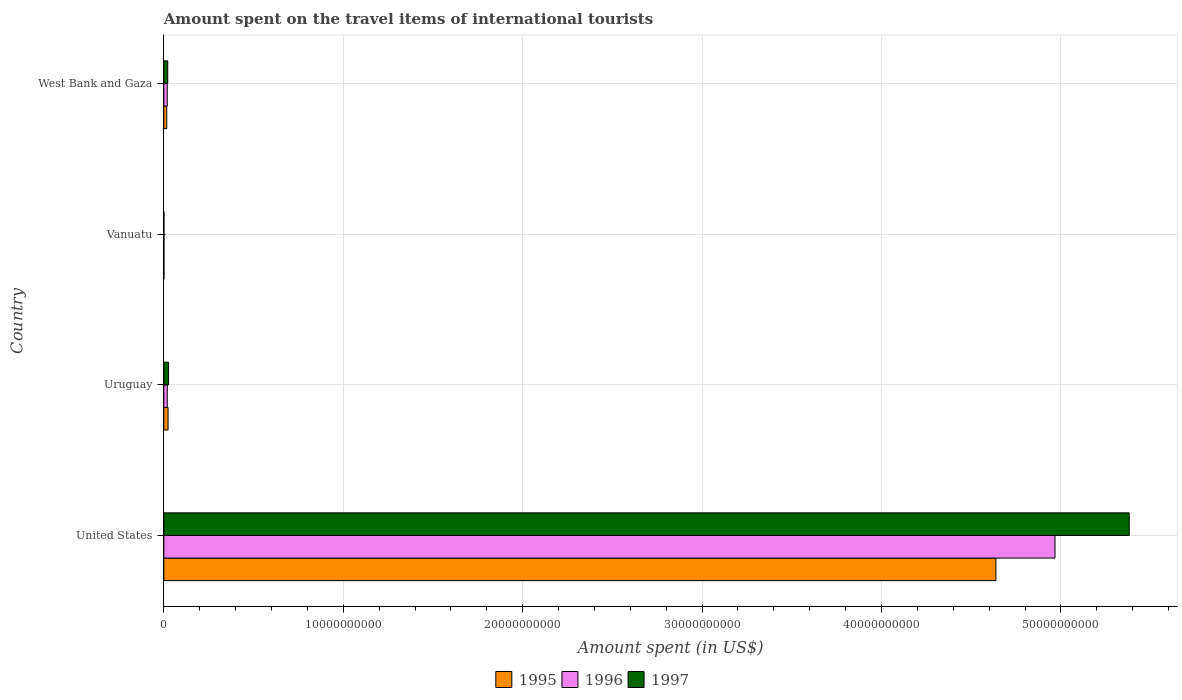How many different coloured bars are there?
Keep it short and to the point. 3. Are the number of bars per tick equal to the number of legend labels?
Your response must be concise. Yes. How many bars are there on the 3rd tick from the top?
Provide a short and direct response. 3. What is the label of the 2nd group of bars from the top?
Your answer should be very brief. Vanuatu. What is the amount spent on the travel items of international tourists in 1996 in Uruguay?
Offer a terse response. 1.92e+08. Across all countries, what is the maximum amount spent on the travel items of international tourists in 1996?
Make the answer very short. 4.97e+1. Across all countries, what is the minimum amount spent on the travel items of international tourists in 1996?
Your answer should be very brief. 5.00e+06. In which country was the amount spent on the travel items of international tourists in 1996 minimum?
Give a very brief answer. Vanuatu. What is the total amount spent on the travel items of international tourists in 1997 in the graph?
Provide a short and direct response. 5.43e+1. What is the difference between the amount spent on the travel items of international tourists in 1997 in United States and that in Uruguay?
Make the answer very short. 5.35e+1. What is the difference between the amount spent on the travel items of international tourists in 1997 in Uruguay and the amount spent on the travel items of international tourists in 1995 in Vanuatu?
Keep it short and to the point. 2.59e+08. What is the average amount spent on the travel items of international tourists in 1997 per country?
Offer a terse response. 1.36e+1. What is the difference between the amount spent on the travel items of international tourists in 1997 and amount spent on the travel items of international tourists in 1995 in Uruguay?
Offer a terse response. 2.80e+07. In how many countries, is the amount spent on the travel items of international tourists in 1995 greater than 50000000000 US$?
Ensure brevity in your answer.  0. What is the ratio of the amount spent on the travel items of international tourists in 1997 in United States to that in West Bank and Gaza?
Ensure brevity in your answer.  246.83. What is the difference between the highest and the second highest amount spent on the travel items of international tourists in 1997?
Offer a terse response. 5.35e+1. What is the difference between the highest and the lowest amount spent on the travel items of international tourists in 1995?
Ensure brevity in your answer.  4.64e+1. Is the sum of the amount spent on the travel items of international tourists in 1997 in Vanuatu and West Bank and Gaza greater than the maximum amount spent on the travel items of international tourists in 1995 across all countries?
Ensure brevity in your answer.  No. What does the 2nd bar from the top in Vanuatu represents?
Provide a short and direct response. 1996. What does the 1st bar from the bottom in Uruguay represents?
Offer a terse response. 1995. Is it the case that in every country, the sum of the amount spent on the travel items of international tourists in 1997 and amount spent on the travel items of international tourists in 1996 is greater than the amount spent on the travel items of international tourists in 1995?
Provide a succinct answer. Yes. What is the difference between two consecutive major ticks on the X-axis?
Provide a short and direct response. 1.00e+1. Does the graph contain grids?
Ensure brevity in your answer.  Yes. Where does the legend appear in the graph?
Offer a very short reply. Bottom center. How many legend labels are there?
Keep it short and to the point. 3. What is the title of the graph?
Keep it short and to the point. Amount spent on the travel items of international tourists. What is the label or title of the X-axis?
Your answer should be very brief. Amount spent (in US$). What is the Amount spent (in US$) in 1995 in United States?
Your response must be concise. 4.64e+1. What is the Amount spent (in US$) in 1996 in United States?
Your response must be concise. 4.97e+1. What is the Amount spent (in US$) of 1997 in United States?
Keep it short and to the point. 5.38e+1. What is the Amount spent (in US$) in 1995 in Uruguay?
Provide a succinct answer. 2.36e+08. What is the Amount spent (in US$) of 1996 in Uruguay?
Make the answer very short. 1.92e+08. What is the Amount spent (in US$) of 1997 in Uruguay?
Provide a short and direct response. 2.64e+08. What is the Amount spent (in US$) of 1995 in Vanuatu?
Keep it short and to the point. 5.00e+06. What is the Amount spent (in US$) in 1995 in West Bank and Gaza?
Provide a short and direct response. 1.62e+08. What is the Amount spent (in US$) in 1996 in West Bank and Gaza?
Your answer should be compact. 1.91e+08. What is the Amount spent (in US$) in 1997 in West Bank and Gaza?
Ensure brevity in your answer.  2.18e+08. Across all countries, what is the maximum Amount spent (in US$) of 1995?
Offer a terse response. 4.64e+1. Across all countries, what is the maximum Amount spent (in US$) in 1996?
Offer a terse response. 4.97e+1. Across all countries, what is the maximum Amount spent (in US$) in 1997?
Keep it short and to the point. 5.38e+1. Across all countries, what is the minimum Amount spent (in US$) in 1995?
Your answer should be very brief. 5.00e+06. Across all countries, what is the minimum Amount spent (in US$) in 1996?
Make the answer very short. 5.00e+06. Across all countries, what is the minimum Amount spent (in US$) in 1997?
Offer a terse response. 5.00e+06. What is the total Amount spent (in US$) in 1995 in the graph?
Give a very brief answer. 4.68e+1. What is the total Amount spent (in US$) of 1996 in the graph?
Offer a terse response. 5.01e+1. What is the total Amount spent (in US$) in 1997 in the graph?
Keep it short and to the point. 5.43e+1. What is the difference between the Amount spent (in US$) in 1995 in United States and that in Uruguay?
Ensure brevity in your answer.  4.61e+1. What is the difference between the Amount spent (in US$) in 1996 in United States and that in Uruguay?
Your response must be concise. 4.95e+1. What is the difference between the Amount spent (in US$) of 1997 in United States and that in Uruguay?
Ensure brevity in your answer.  5.35e+1. What is the difference between the Amount spent (in US$) of 1995 in United States and that in Vanuatu?
Your response must be concise. 4.64e+1. What is the difference between the Amount spent (in US$) of 1996 in United States and that in Vanuatu?
Ensure brevity in your answer.  4.97e+1. What is the difference between the Amount spent (in US$) in 1997 in United States and that in Vanuatu?
Offer a terse response. 5.38e+1. What is the difference between the Amount spent (in US$) of 1995 in United States and that in West Bank and Gaza?
Keep it short and to the point. 4.62e+1. What is the difference between the Amount spent (in US$) of 1996 in United States and that in West Bank and Gaza?
Provide a short and direct response. 4.95e+1. What is the difference between the Amount spent (in US$) in 1997 in United States and that in West Bank and Gaza?
Make the answer very short. 5.36e+1. What is the difference between the Amount spent (in US$) in 1995 in Uruguay and that in Vanuatu?
Provide a short and direct response. 2.31e+08. What is the difference between the Amount spent (in US$) of 1996 in Uruguay and that in Vanuatu?
Provide a succinct answer. 1.87e+08. What is the difference between the Amount spent (in US$) in 1997 in Uruguay and that in Vanuatu?
Your answer should be very brief. 2.59e+08. What is the difference between the Amount spent (in US$) of 1995 in Uruguay and that in West Bank and Gaza?
Your answer should be very brief. 7.40e+07. What is the difference between the Amount spent (in US$) in 1996 in Uruguay and that in West Bank and Gaza?
Offer a terse response. 1.00e+06. What is the difference between the Amount spent (in US$) in 1997 in Uruguay and that in West Bank and Gaza?
Make the answer very short. 4.60e+07. What is the difference between the Amount spent (in US$) in 1995 in Vanuatu and that in West Bank and Gaza?
Your answer should be very brief. -1.57e+08. What is the difference between the Amount spent (in US$) of 1996 in Vanuatu and that in West Bank and Gaza?
Your response must be concise. -1.86e+08. What is the difference between the Amount spent (in US$) in 1997 in Vanuatu and that in West Bank and Gaza?
Give a very brief answer. -2.13e+08. What is the difference between the Amount spent (in US$) of 1995 in United States and the Amount spent (in US$) of 1996 in Uruguay?
Provide a succinct answer. 4.62e+1. What is the difference between the Amount spent (in US$) of 1995 in United States and the Amount spent (in US$) of 1997 in Uruguay?
Provide a short and direct response. 4.61e+1. What is the difference between the Amount spent (in US$) in 1996 in United States and the Amount spent (in US$) in 1997 in Uruguay?
Ensure brevity in your answer.  4.94e+1. What is the difference between the Amount spent (in US$) in 1995 in United States and the Amount spent (in US$) in 1996 in Vanuatu?
Offer a terse response. 4.64e+1. What is the difference between the Amount spent (in US$) of 1995 in United States and the Amount spent (in US$) of 1997 in Vanuatu?
Offer a very short reply. 4.64e+1. What is the difference between the Amount spent (in US$) of 1996 in United States and the Amount spent (in US$) of 1997 in Vanuatu?
Provide a short and direct response. 4.97e+1. What is the difference between the Amount spent (in US$) of 1995 in United States and the Amount spent (in US$) of 1996 in West Bank and Gaza?
Your answer should be compact. 4.62e+1. What is the difference between the Amount spent (in US$) in 1995 in United States and the Amount spent (in US$) in 1997 in West Bank and Gaza?
Offer a very short reply. 4.62e+1. What is the difference between the Amount spent (in US$) of 1996 in United States and the Amount spent (in US$) of 1997 in West Bank and Gaza?
Your response must be concise. 4.95e+1. What is the difference between the Amount spent (in US$) of 1995 in Uruguay and the Amount spent (in US$) of 1996 in Vanuatu?
Your response must be concise. 2.31e+08. What is the difference between the Amount spent (in US$) in 1995 in Uruguay and the Amount spent (in US$) in 1997 in Vanuatu?
Your answer should be very brief. 2.31e+08. What is the difference between the Amount spent (in US$) of 1996 in Uruguay and the Amount spent (in US$) of 1997 in Vanuatu?
Your response must be concise. 1.87e+08. What is the difference between the Amount spent (in US$) in 1995 in Uruguay and the Amount spent (in US$) in 1996 in West Bank and Gaza?
Provide a short and direct response. 4.50e+07. What is the difference between the Amount spent (in US$) of 1995 in Uruguay and the Amount spent (in US$) of 1997 in West Bank and Gaza?
Offer a very short reply. 1.80e+07. What is the difference between the Amount spent (in US$) of 1996 in Uruguay and the Amount spent (in US$) of 1997 in West Bank and Gaza?
Offer a very short reply. -2.60e+07. What is the difference between the Amount spent (in US$) in 1995 in Vanuatu and the Amount spent (in US$) in 1996 in West Bank and Gaza?
Provide a short and direct response. -1.86e+08. What is the difference between the Amount spent (in US$) in 1995 in Vanuatu and the Amount spent (in US$) in 1997 in West Bank and Gaza?
Your answer should be very brief. -2.13e+08. What is the difference between the Amount spent (in US$) in 1996 in Vanuatu and the Amount spent (in US$) in 1997 in West Bank and Gaza?
Your response must be concise. -2.13e+08. What is the average Amount spent (in US$) of 1995 per country?
Provide a succinct answer. 1.17e+1. What is the average Amount spent (in US$) of 1996 per country?
Keep it short and to the point. 1.25e+1. What is the average Amount spent (in US$) of 1997 per country?
Make the answer very short. 1.36e+1. What is the difference between the Amount spent (in US$) in 1995 and Amount spent (in US$) in 1996 in United States?
Give a very brief answer. -3.29e+09. What is the difference between the Amount spent (in US$) of 1995 and Amount spent (in US$) of 1997 in United States?
Provide a succinct answer. -7.43e+09. What is the difference between the Amount spent (in US$) in 1996 and Amount spent (in US$) in 1997 in United States?
Ensure brevity in your answer.  -4.14e+09. What is the difference between the Amount spent (in US$) in 1995 and Amount spent (in US$) in 1996 in Uruguay?
Give a very brief answer. 4.40e+07. What is the difference between the Amount spent (in US$) in 1995 and Amount spent (in US$) in 1997 in Uruguay?
Keep it short and to the point. -2.80e+07. What is the difference between the Amount spent (in US$) of 1996 and Amount spent (in US$) of 1997 in Uruguay?
Keep it short and to the point. -7.20e+07. What is the difference between the Amount spent (in US$) of 1995 and Amount spent (in US$) of 1997 in Vanuatu?
Give a very brief answer. 0. What is the difference between the Amount spent (in US$) in 1995 and Amount spent (in US$) in 1996 in West Bank and Gaza?
Give a very brief answer. -2.90e+07. What is the difference between the Amount spent (in US$) in 1995 and Amount spent (in US$) in 1997 in West Bank and Gaza?
Keep it short and to the point. -5.60e+07. What is the difference between the Amount spent (in US$) in 1996 and Amount spent (in US$) in 1997 in West Bank and Gaza?
Offer a terse response. -2.70e+07. What is the ratio of the Amount spent (in US$) in 1995 in United States to that in Uruguay?
Provide a succinct answer. 196.52. What is the ratio of the Amount spent (in US$) in 1996 in United States to that in Uruguay?
Give a very brief answer. 258.71. What is the ratio of the Amount spent (in US$) in 1997 in United States to that in Uruguay?
Your answer should be compact. 203.82. What is the ratio of the Amount spent (in US$) in 1995 in United States to that in Vanuatu?
Offer a terse response. 9275.8. What is the ratio of the Amount spent (in US$) in 1996 in United States to that in Vanuatu?
Ensure brevity in your answer.  9934.4. What is the ratio of the Amount spent (in US$) in 1997 in United States to that in Vanuatu?
Ensure brevity in your answer.  1.08e+04. What is the ratio of the Amount spent (in US$) in 1995 in United States to that in West Bank and Gaza?
Make the answer very short. 286.29. What is the ratio of the Amount spent (in US$) of 1996 in United States to that in West Bank and Gaza?
Your response must be concise. 260.06. What is the ratio of the Amount spent (in US$) of 1997 in United States to that in West Bank and Gaza?
Make the answer very short. 246.83. What is the ratio of the Amount spent (in US$) in 1995 in Uruguay to that in Vanuatu?
Your response must be concise. 47.2. What is the ratio of the Amount spent (in US$) of 1996 in Uruguay to that in Vanuatu?
Make the answer very short. 38.4. What is the ratio of the Amount spent (in US$) of 1997 in Uruguay to that in Vanuatu?
Provide a short and direct response. 52.8. What is the ratio of the Amount spent (in US$) of 1995 in Uruguay to that in West Bank and Gaza?
Make the answer very short. 1.46. What is the ratio of the Amount spent (in US$) in 1996 in Uruguay to that in West Bank and Gaza?
Offer a very short reply. 1.01. What is the ratio of the Amount spent (in US$) of 1997 in Uruguay to that in West Bank and Gaza?
Make the answer very short. 1.21. What is the ratio of the Amount spent (in US$) in 1995 in Vanuatu to that in West Bank and Gaza?
Provide a short and direct response. 0.03. What is the ratio of the Amount spent (in US$) in 1996 in Vanuatu to that in West Bank and Gaza?
Give a very brief answer. 0.03. What is the ratio of the Amount spent (in US$) in 1997 in Vanuatu to that in West Bank and Gaza?
Offer a terse response. 0.02. What is the difference between the highest and the second highest Amount spent (in US$) of 1995?
Give a very brief answer. 4.61e+1. What is the difference between the highest and the second highest Amount spent (in US$) in 1996?
Your answer should be very brief. 4.95e+1. What is the difference between the highest and the second highest Amount spent (in US$) of 1997?
Your response must be concise. 5.35e+1. What is the difference between the highest and the lowest Amount spent (in US$) in 1995?
Keep it short and to the point. 4.64e+1. What is the difference between the highest and the lowest Amount spent (in US$) of 1996?
Ensure brevity in your answer.  4.97e+1. What is the difference between the highest and the lowest Amount spent (in US$) of 1997?
Ensure brevity in your answer.  5.38e+1. 